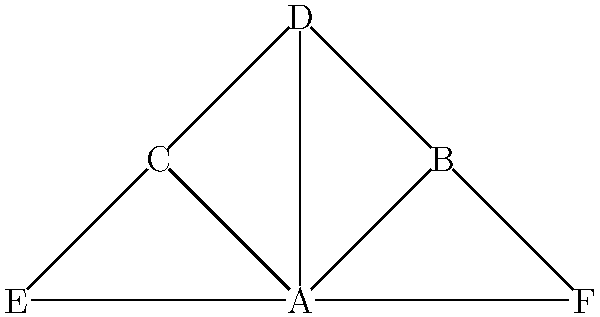In the social network graph above, which node would be considered the most influential in terms of information flow, and how might this node potentially become an information bottleneck? Justify your answer using network analysis concepts. To determine the most influential node and potential information bottleneck, we need to analyze the graph using several network centrality measures:

1. Degree Centrality: Count the number of connections each node has.
   A: 5, B: 2, C: 3, D: 3, E: 2, F: 2
   Node A has the highest degree centrality.

2. Betweenness Centrality: Measure how often a node acts as a bridge along the shortest path between two other nodes.
   Node A appears in the most shortest paths between other nodes.

3. Closeness Centrality: Calculate the average shortest path length from a node to all other nodes.
   Node A has the shortest average path length to all other nodes.

4. Eigenvector Centrality: Measure a node's influence based on the importance of its connections.
   Node A would likely have the highest eigenvector centrality due to its central position and connections to all other nodes.

Based on these analyses, Node A is the most influential in terms of information flow because:
- It has the most direct connections (highest degree centrality)
- It acts as a central hub for information passing between other nodes (highest betweenness centrality)
- It can reach all other nodes quickly (highest closeness centrality)
- It is connected to other relatively important nodes (likely highest eigenvector centrality)

Node A could become an information bottleneck because:
- All information must pass through it to reach other parts of the network
- If Node A is removed or compromised, the network would be severely disrupted
- Node A may become overwhelmed with information, slowing down the overall flow in the network

This centralized structure makes the network efficient but also vulnerable to disruptions at the central node.
Answer: Node A; central position creates efficiency but risk of bottleneck 